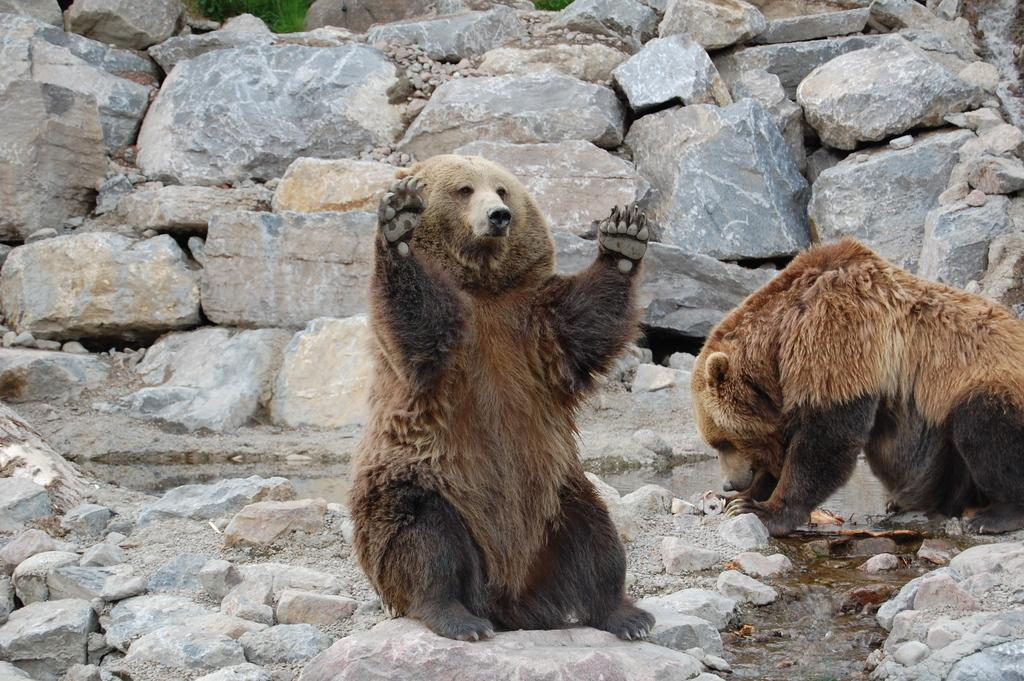How many animals are present in the image? There are two animals in the image. What can be seen behind the animals in the image? There are rocks behind the animals in the image. What type of pickle is being used to treat the disease in the image? There is no pickle or disease present in the image; it features two animals and rocks in the background. 